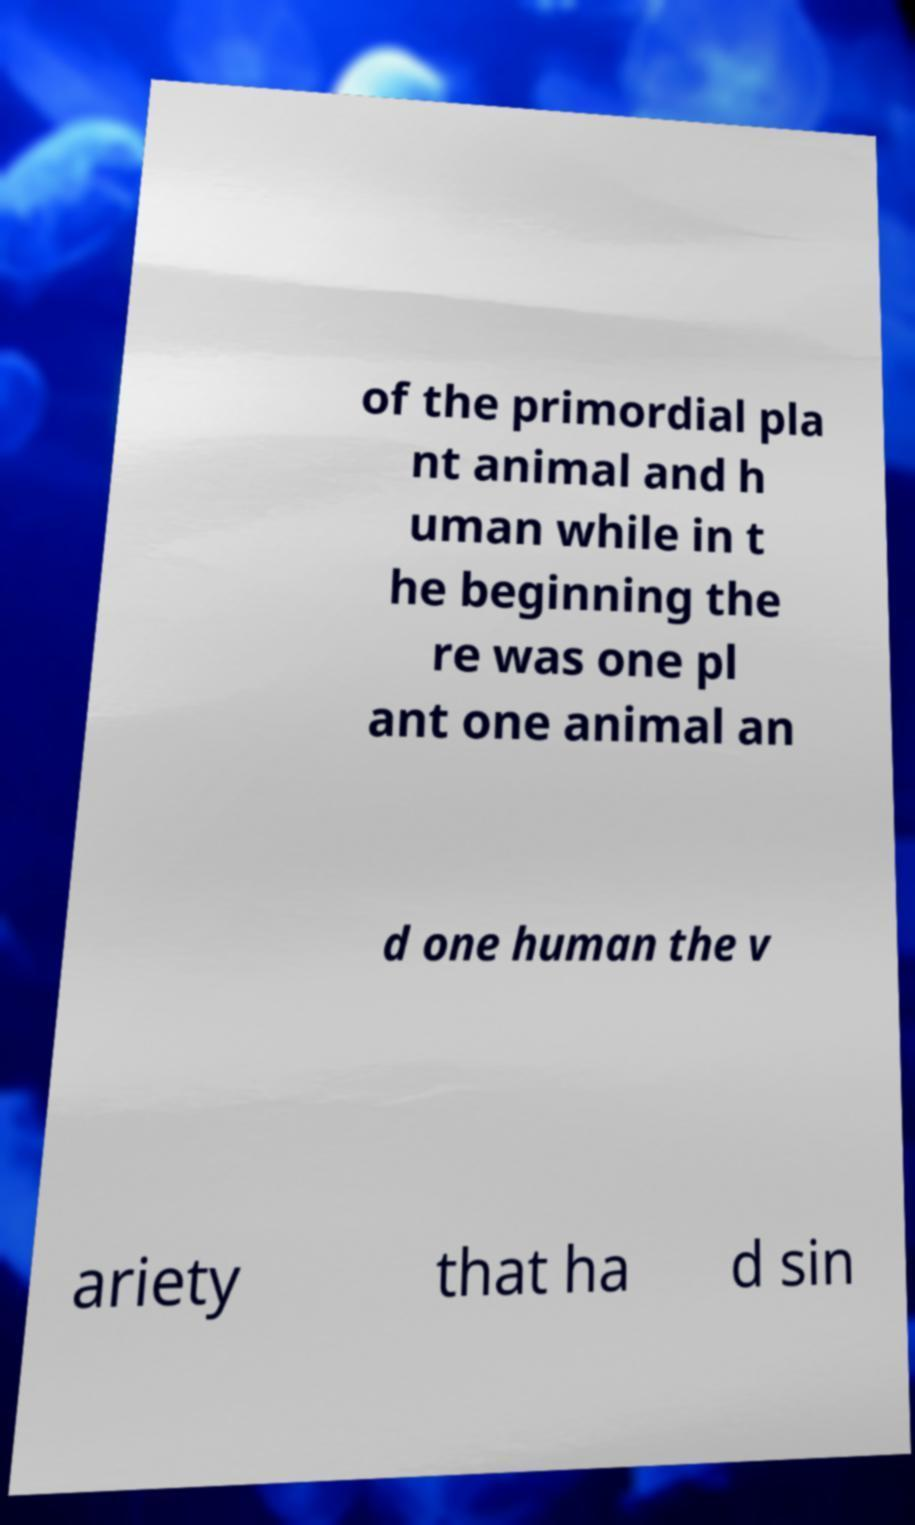Could you assist in decoding the text presented in this image and type it out clearly? of the primordial pla nt animal and h uman while in t he beginning the re was one pl ant one animal an d one human the v ariety that ha d sin 